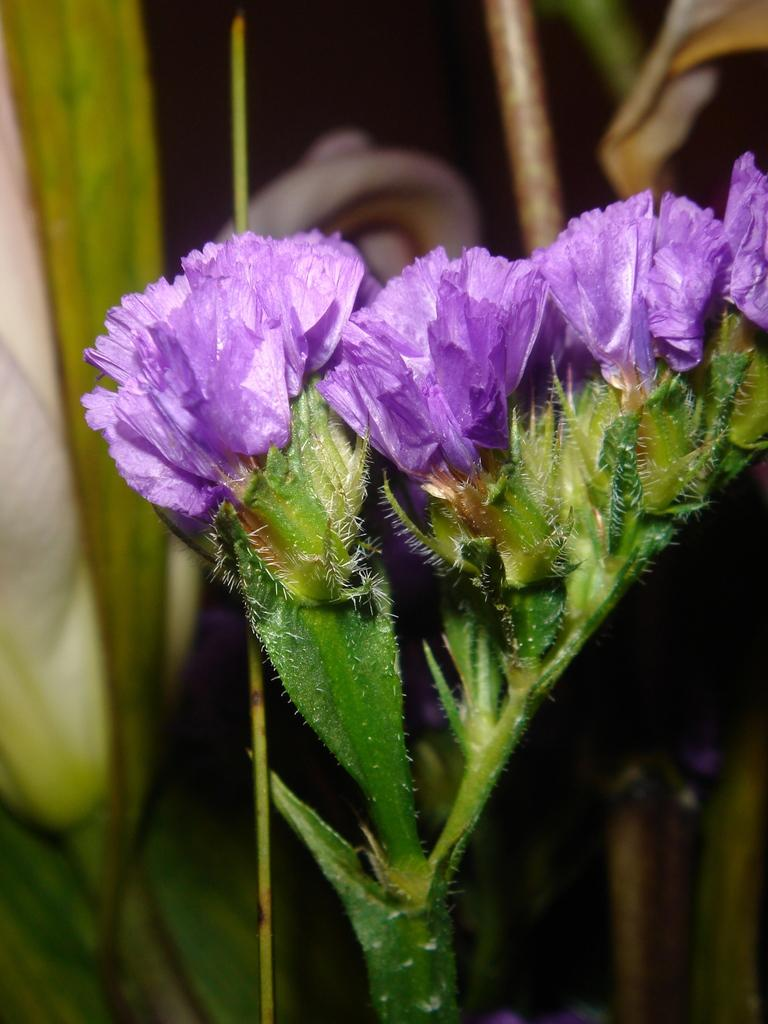What type of living organisms can be seen in the image? Flowers and plants are visible in the image. Can you describe the background of the image? The background of the image is dark. Is there a volcano erupting in the background of the image? No, there is no volcano present in the image. Can you see a kiss between two people in the image? There is no kiss or people present in the image; it features flowers and plants. 